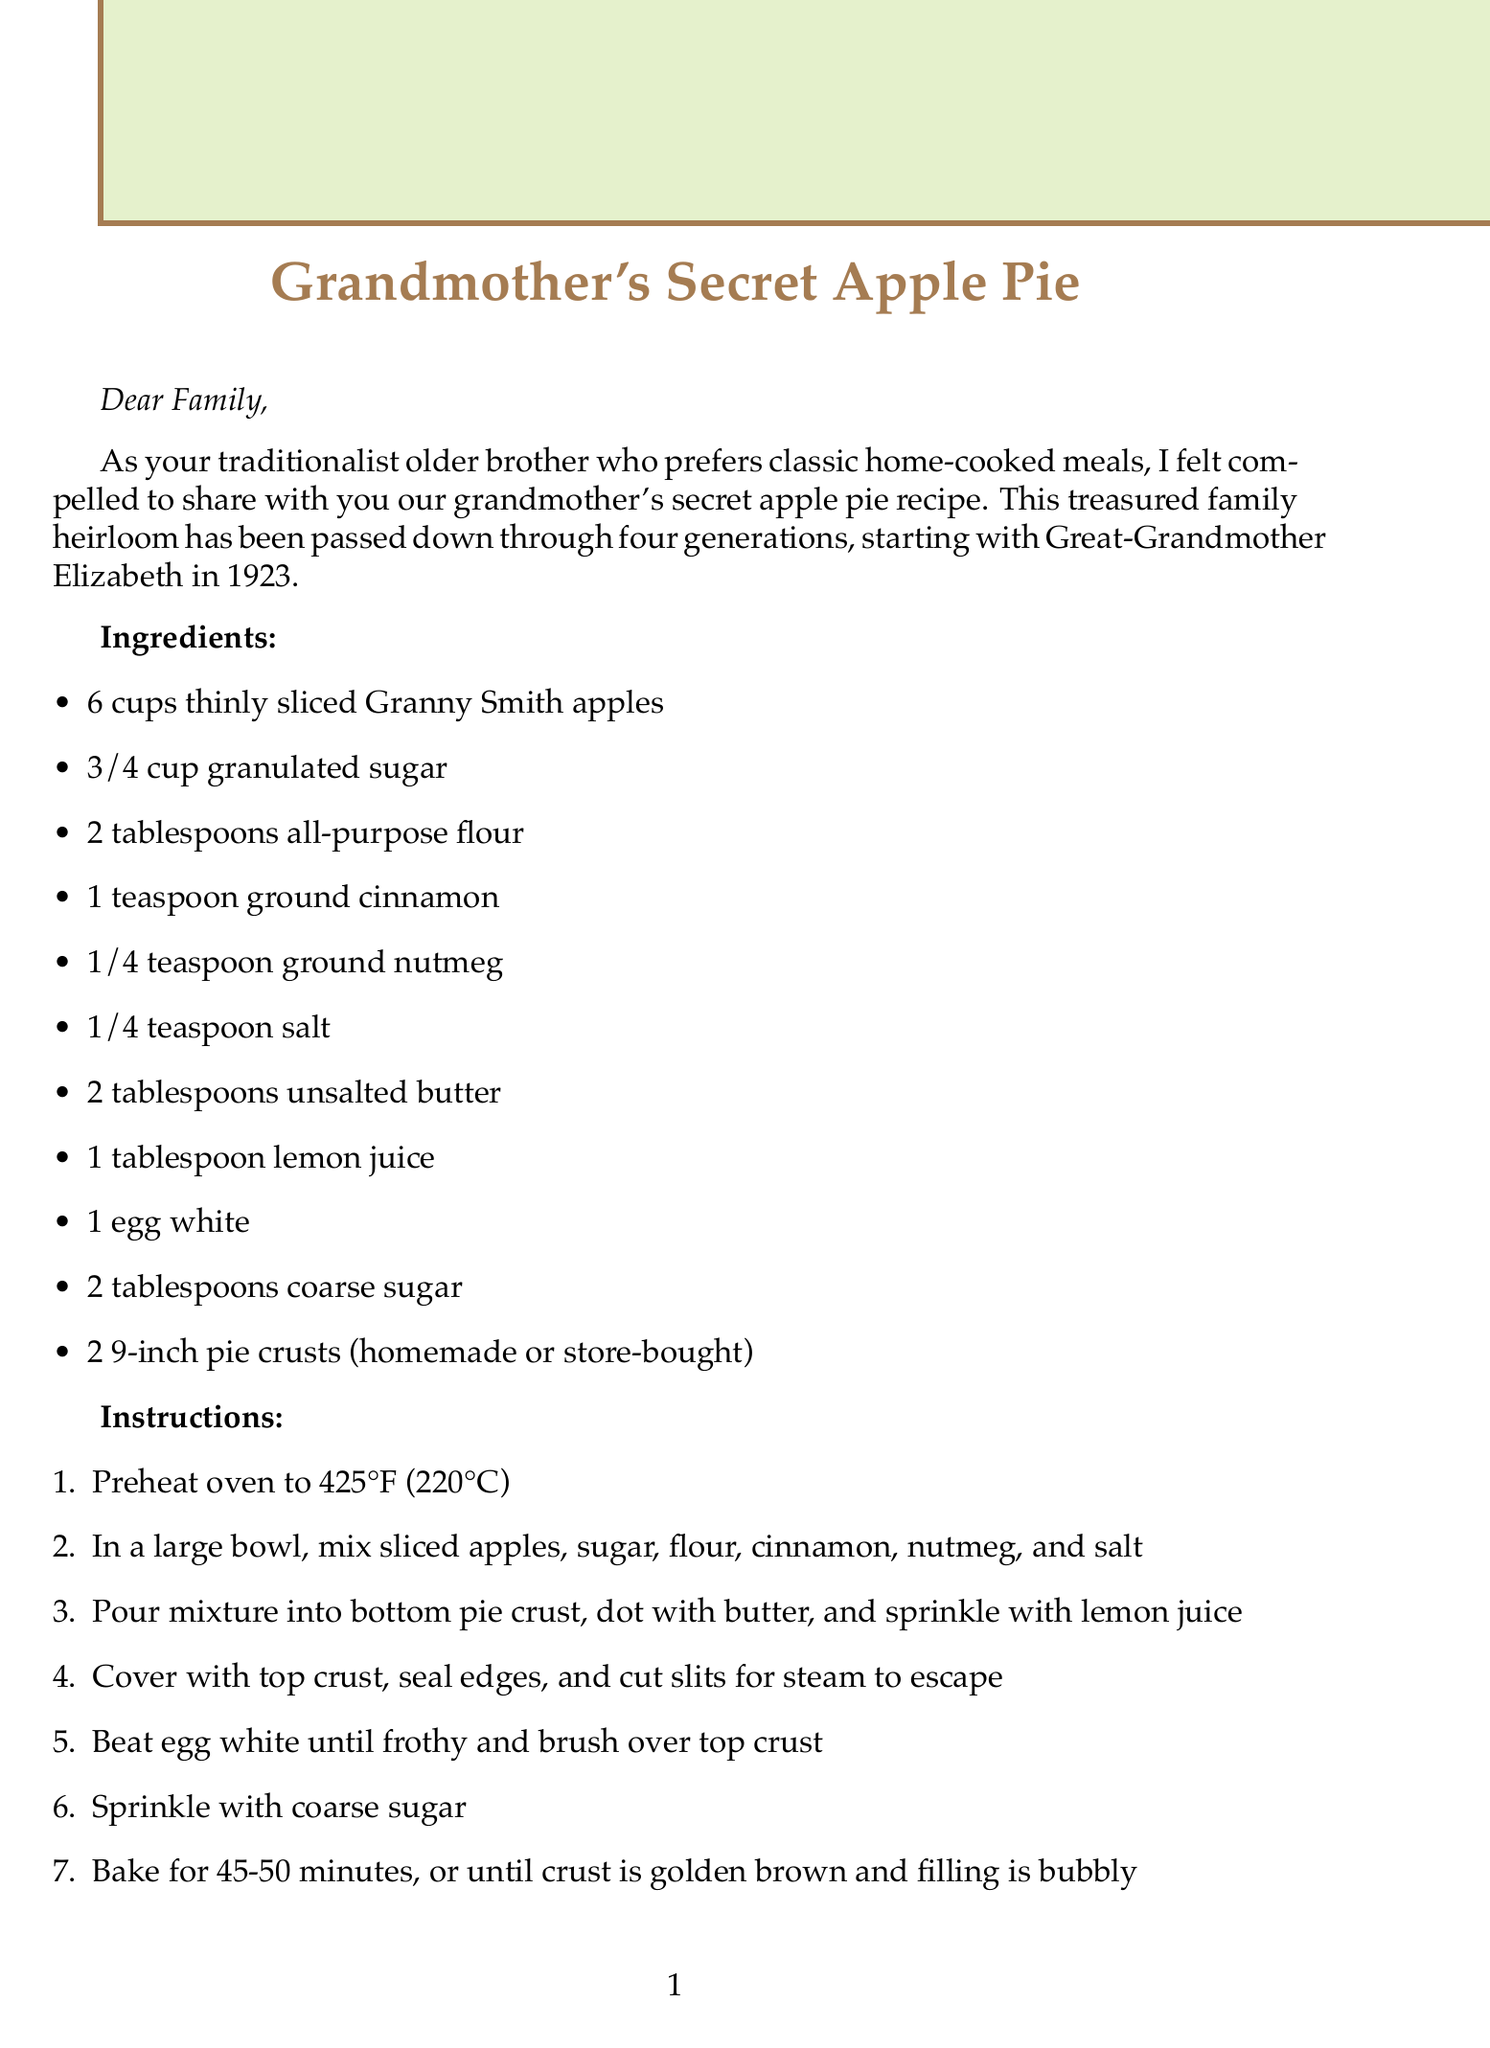What is the recipe title? The recipe title is mentioned at the beginning of the document, highlighting the specific dish being discussed.
Answer: Grandmother's Secret Apple Pie How many cups of apples are needed? The ingredients list specifies the exact amount of apples needed for the recipe.
Answer: 6 cups What type of apples should be used? The secret tip section emphasizes the importance of using a specific type of apple for the recipe's success.
Answer: Granny Smith What is the baking temperature? The instructions clearly state the temperature at which the pie should be baked.
Answer: 425°F (220°C) What year did the recipe originate? The family history section mentions the year the recipe was first passed down in the family.
Answer: 1923 How long should the pie be baked? The instructions provide a specific timeframe for how long the pie needs to be in the oven.
Answer: 45-50 minutes What is the personal note about? The personal note provides an emotional connection to the activity of baking the pie and its significance.
Answer: The smell of a freshly baked apple pie filling the house What is the suggested beverage pairing? The document includes a recommendation for a beverage that complements the dessert.
Answer: Black tea or coffee 